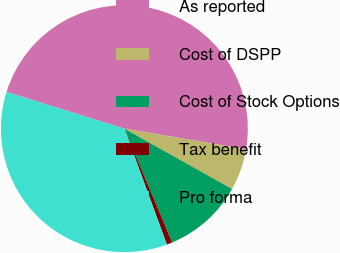Convert chart. <chart><loc_0><loc_0><loc_500><loc_500><pie_chart><fcel>As reported<fcel>Cost of DSPP<fcel>Cost of Stock Options<fcel>Tax benefit<fcel>Pro forma<nl><fcel>47.87%<fcel>5.45%<fcel>10.55%<fcel>0.73%<fcel>35.4%<nl></chart> 